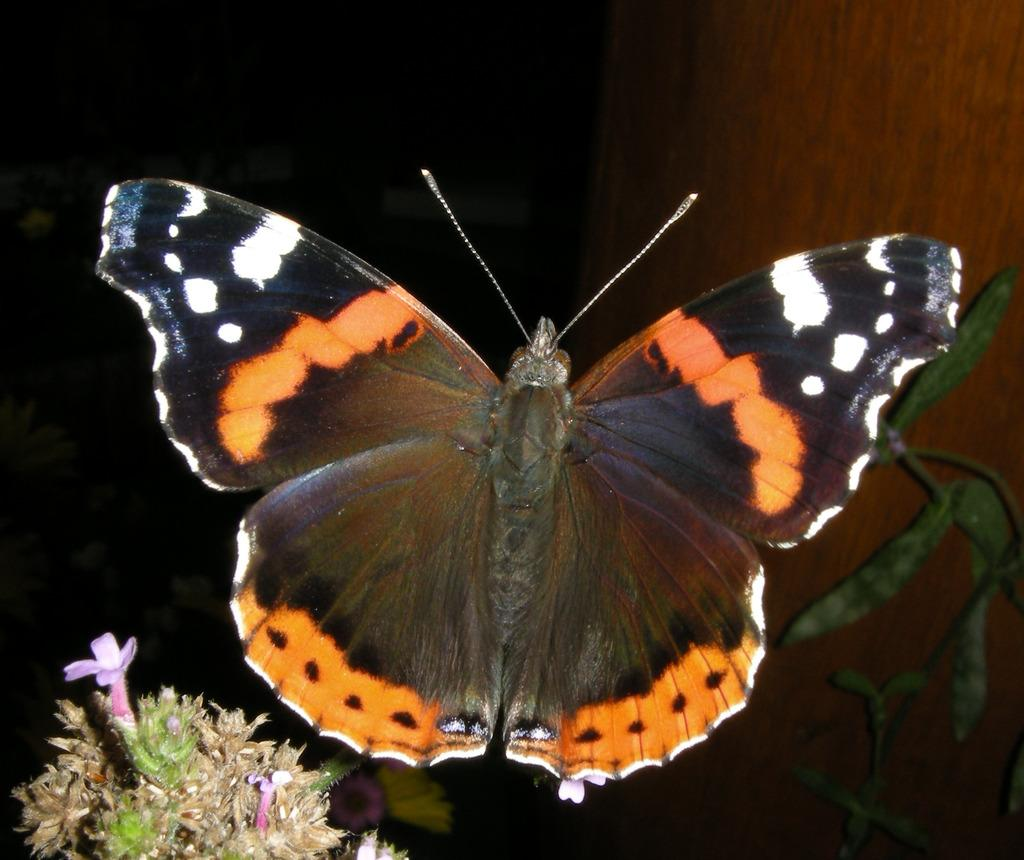What is on the plant in the image? There is a butterfly on a plant in the image. What can be observed about the plant with the butterfly? The plant has leaves. What type of plant can be seen in the left bottom of the image? There is a plant with flowers in the left bottom of the image. What is located on the right side of the image? There is a wooden trunk on the right side of the image. What type of doctor is examining the butterfly in the image? There is no doctor present in the image, and the butterfly is not being examined by anyone. 